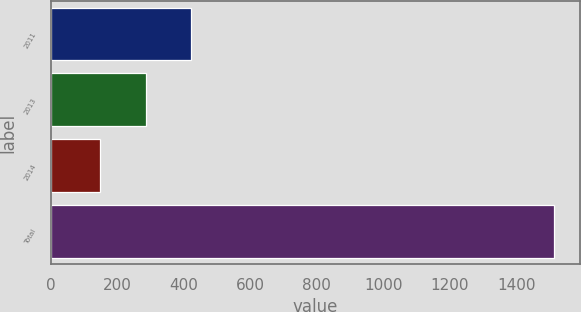<chart> <loc_0><loc_0><loc_500><loc_500><bar_chart><fcel>2011<fcel>2013<fcel>2014<fcel>Total<nl><fcel>423<fcel>286.5<fcel>150<fcel>1515<nl></chart> 